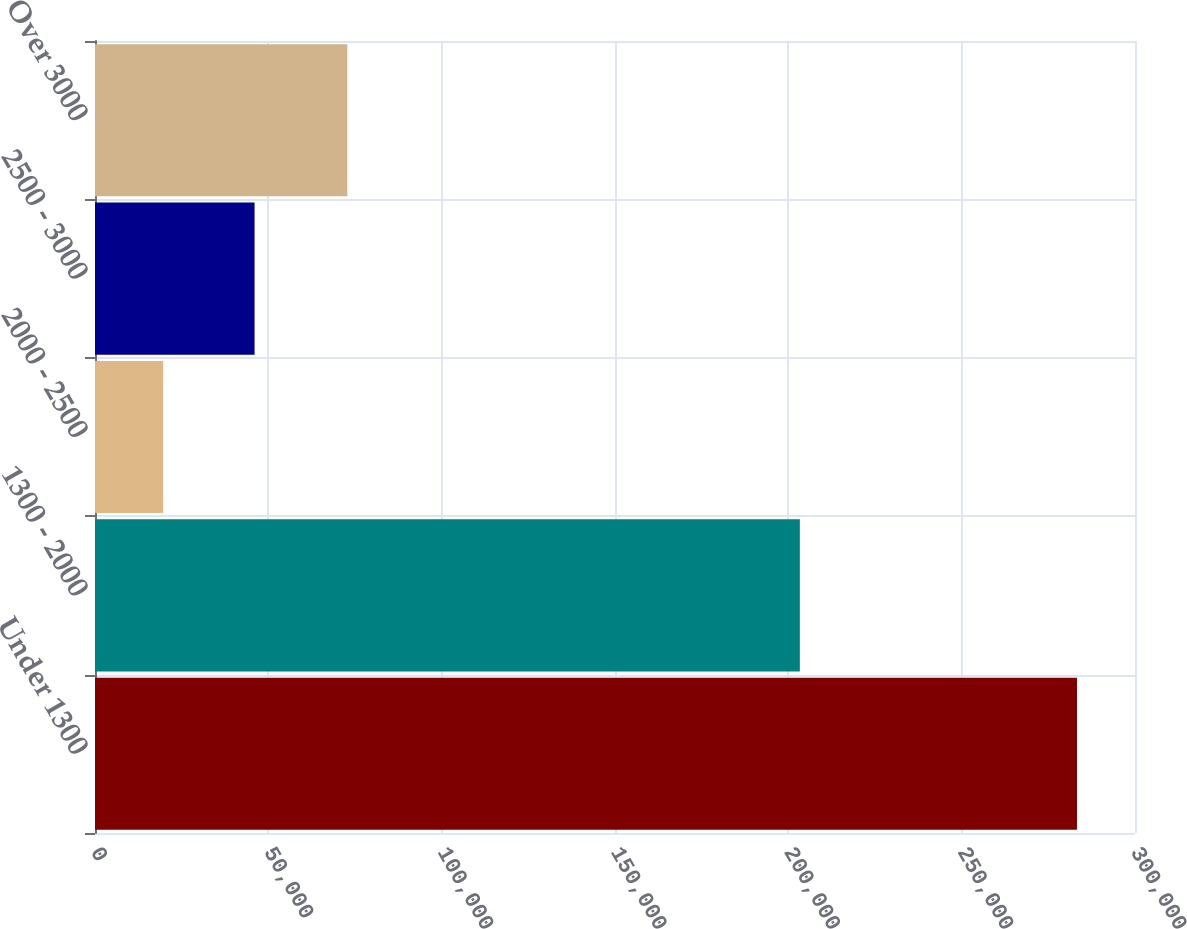Convert chart to OTSL. <chart><loc_0><loc_0><loc_500><loc_500><bar_chart><fcel>Under 1300<fcel>1300 - 2000<fcel>2000 - 2500<fcel>2500 - 3000<fcel>Over 3000<nl><fcel>283264<fcel>203321<fcel>19667<fcel>46026.7<fcel>72788<nl></chart> 